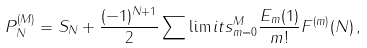Convert formula to latex. <formula><loc_0><loc_0><loc_500><loc_500>& P ^ { ( M ) } _ { N } = S _ { N } + \frac { ( - 1 ) ^ { N + 1 } } { 2 } \sum \lim i t s _ { m = 0 } ^ { M } \frac { E _ { m } ( 1 ) } { m ! } F ^ { ( m ) } ( N ) \, ,</formula> 